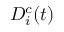Convert formula to latex. <formula><loc_0><loc_0><loc_500><loc_500>D _ { i } ^ { c } ( t )</formula> 